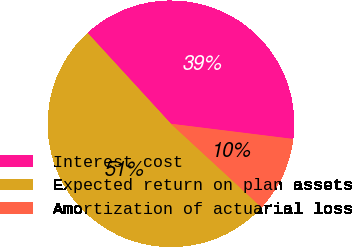<chart> <loc_0><loc_0><loc_500><loc_500><pie_chart><fcel>Interest cost<fcel>Expected return on plan assets<fcel>Amortization of actuarial loss<nl><fcel>38.78%<fcel>51.32%<fcel>9.9%<nl></chart> 